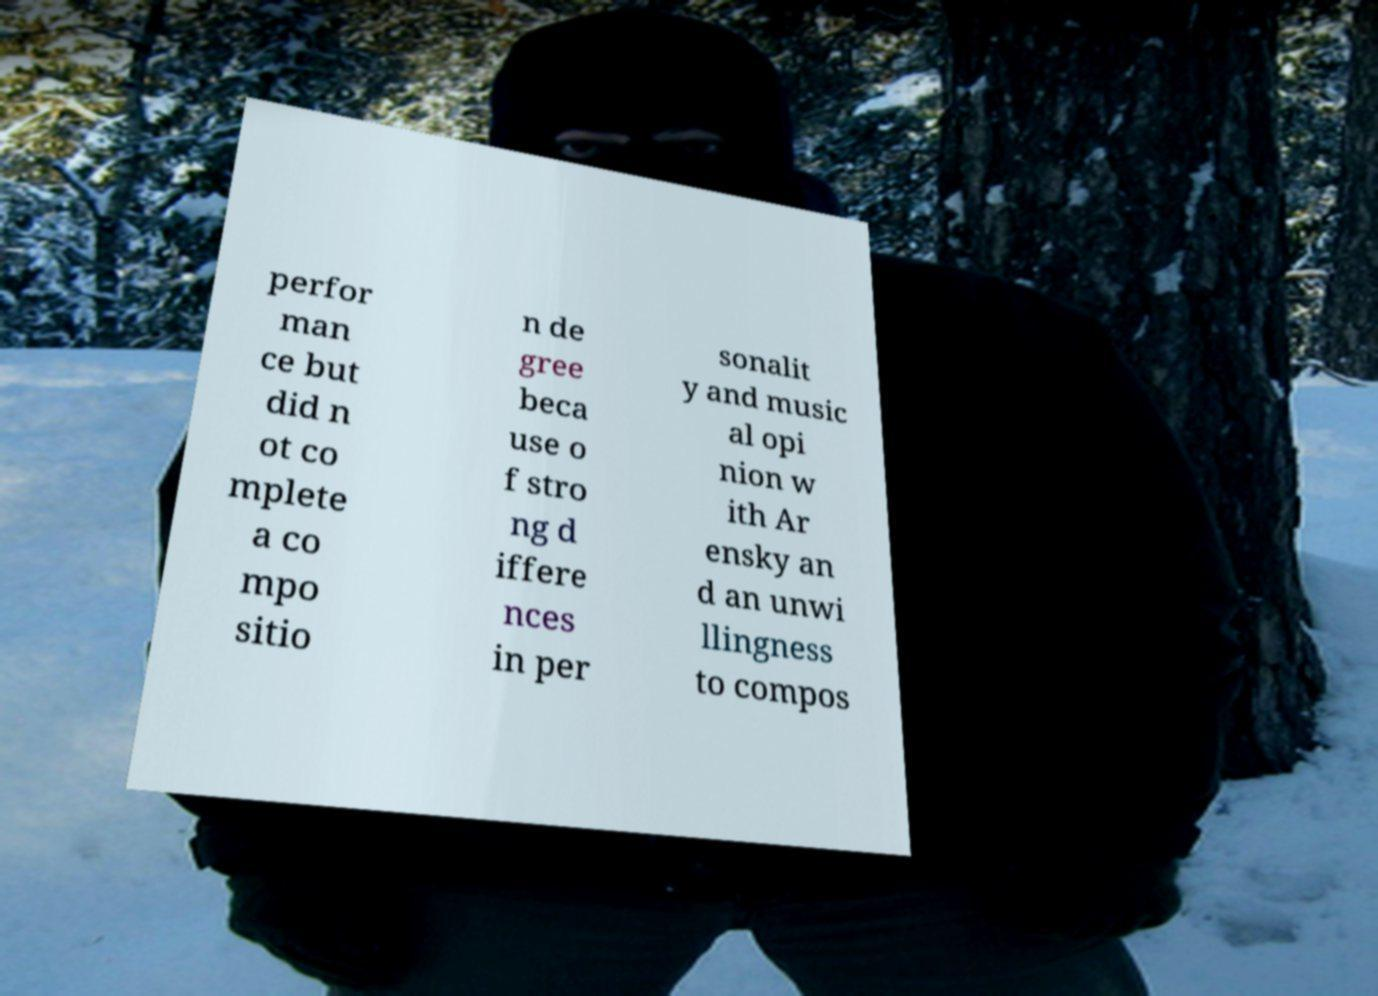Can you read and provide the text displayed in the image?This photo seems to have some interesting text. Can you extract and type it out for me? perfor man ce but did n ot co mplete a co mpo sitio n de gree beca use o f stro ng d iffere nces in per sonalit y and music al opi nion w ith Ar ensky an d an unwi llingness to compos 